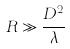Convert formula to latex. <formula><loc_0><loc_0><loc_500><loc_500>R \gg \frac { D ^ { 2 } } { \lambda }</formula> 